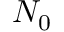<formula> <loc_0><loc_0><loc_500><loc_500>N _ { 0 }</formula> 